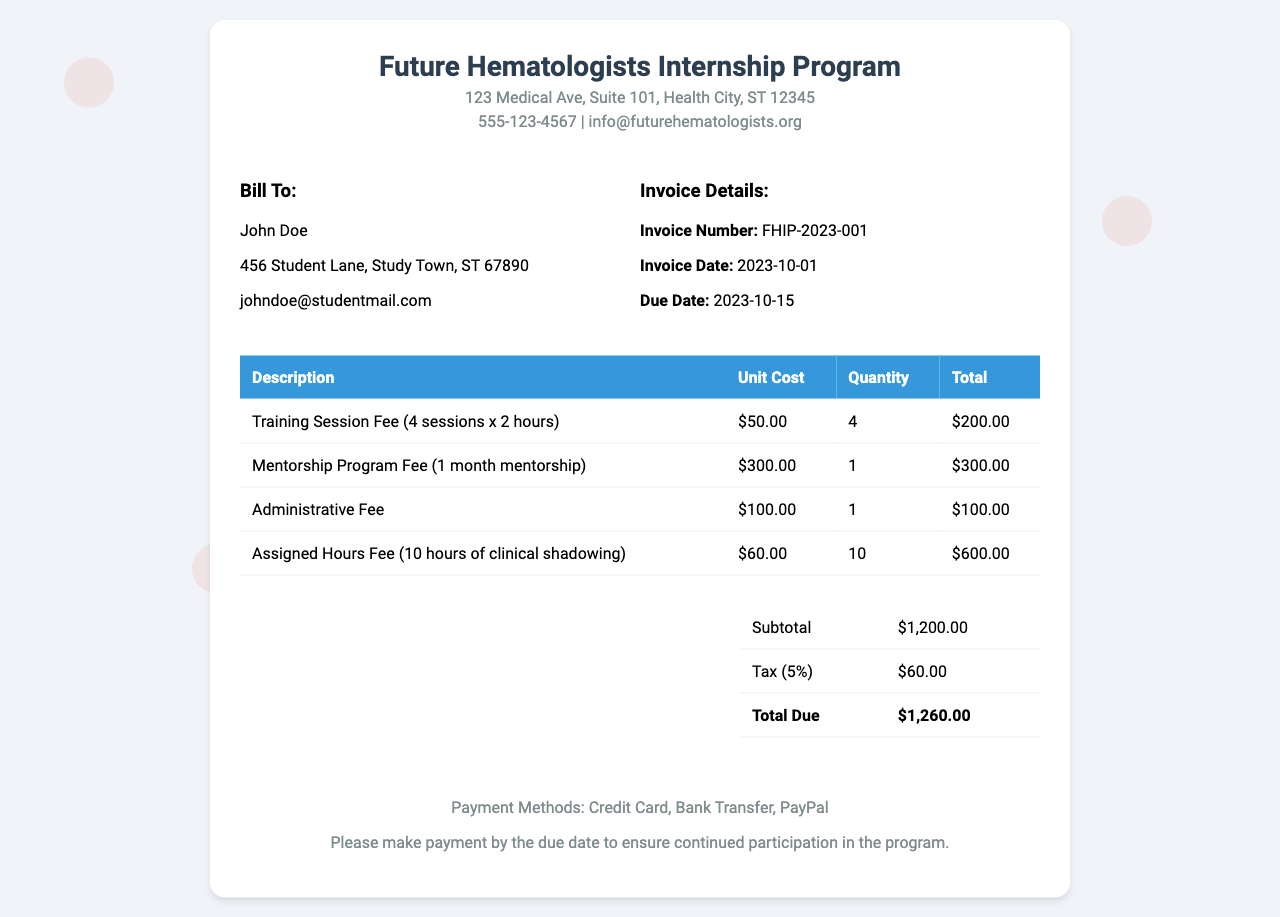What is the invoice number? The invoice number is provided in the invoice details section, which is FHIP-2023-001.
Answer: FHIP-2023-001 What is the total due amount? The total due amount is indicated in the total section and includes subtotal and tax, which results in $1,260.00.
Answer: $1,260.00 How many training sessions are included? There are a total of 4 training sessions mentioned in the description of the training session fee.
Answer: 4 What is the cost of the mentorship program? The cost for the mentorship program fee is clearly stated under the mentorship program fee section, which is $300.00.
Answer: $300.00 What is the due date for payment? The due date is specified in the invoice details section and is set for October 15, 2023.
Answer: 2023-10-15 How many hours of clinical shadowing are assigned? The invoice specifies that there are 10 hours of clinical shadowing under the assigned hours fee.
Answer: 10 What is the tax percentage applied? The invoice shows that a tax of 5% is applied to the subtotal amount.
Answer: 5% What is the administrative fee? The administrative fee is detailed in the invoice, which is $100.00.
Answer: $100.00 What payment methods are accepted? The payment methods section lists Credit Card, Bank Transfer, and PayPal as the options.
Answer: Credit Card, Bank Transfer, PayPal 